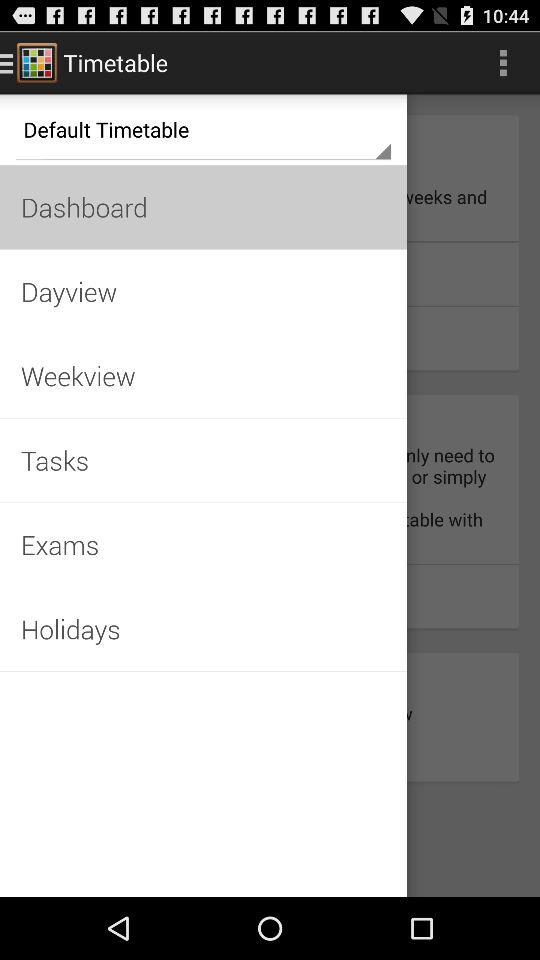What is the name of the application? The name of the application is "Timetable". 